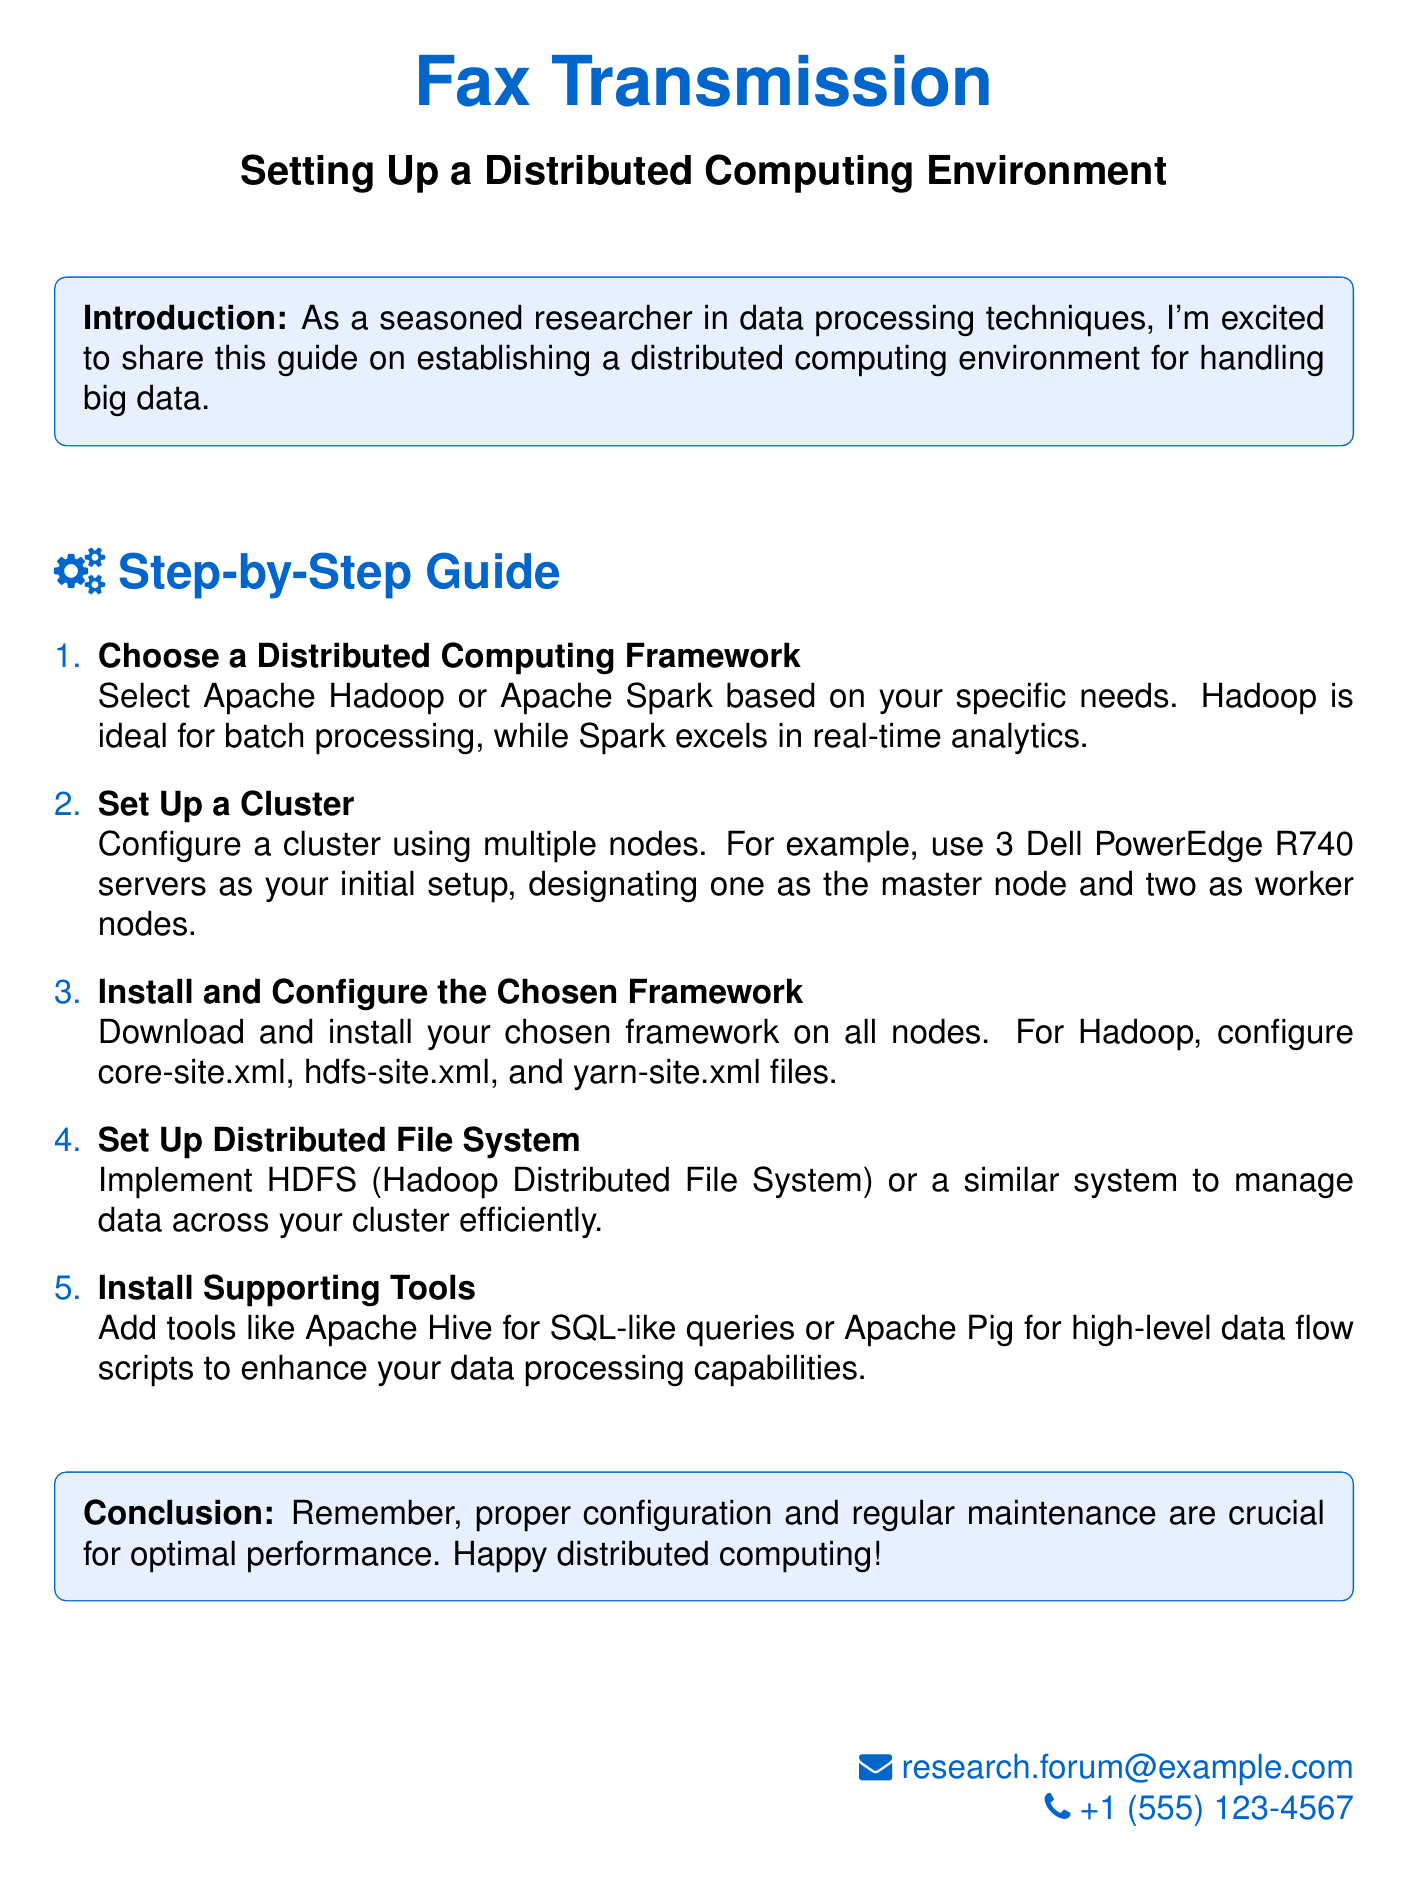What is the title of the document? The title appears prominently at the top of the document.
Answer: Setting Up a Distributed Computing Environment What is the first step in the guide? The first step provides a clear instruction for setting up the environment.
Answer: Choose a Distributed Computing Framework How many nodes are suggested for the initial setup? The document specifies the number of nodes in the setup description.
Answer: 3 Which distributed computing framework is ideal for real-time analytics? The document compares different frameworks and their suitability for tasks.
Answer: Apache Spark What tools are suggested to enhance data processing capabilities? Supporting tools are mentioned to complement the main framework.
Answer: Apache Hive What is the purpose of setting up a distributed file system? The document provides an essential function of the distributed file system.
Answer: Manage data across your cluster efficiently What type of environment does this document guide you to set up? The introduction provides context on the type of environment being discussed.
Answer: Distributed computing environment Why is regular maintenance important according to the conclusion? The conclusion emphasizes a key aspect of managing the setup.
Answer: Optimal performance 